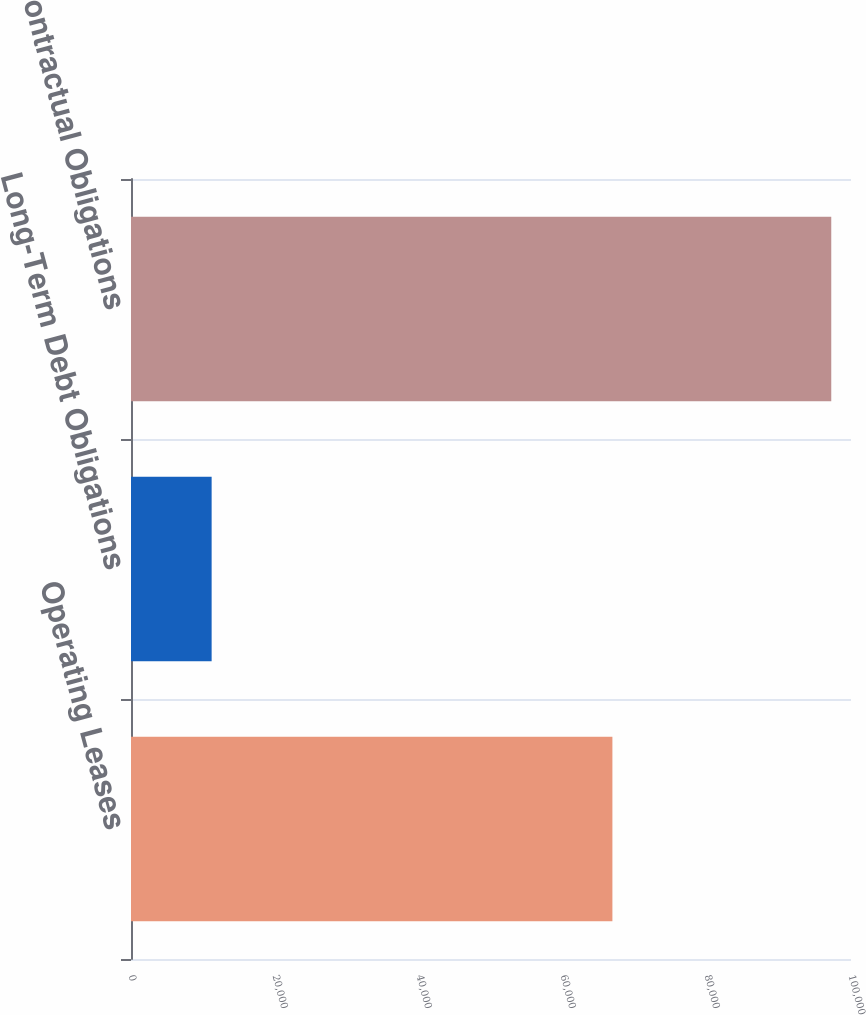Convert chart to OTSL. <chart><loc_0><loc_0><loc_500><loc_500><bar_chart><fcel>Operating Leases<fcel>Long-Term Debt Obligations<fcel>Total Contractual Obligations<nl><fcel>66861<fcel>11199<fcel>97258<nl></chart> 